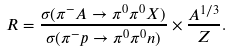Convert formula to latex. <formula><loc_0><loc_0><loc_500><loc_500>R = \frac { \sigma ( \pi ^ { - } A \to \pi ^ { 0 } \pi ^ { 0 } X ) } { \sigma ( \pi ^ { - } p \to \pi ^ { 0 } \pi ^ { 0 } n ) } \times \frac { A ^ { 1 / 3 } } { Z } .</formula> 